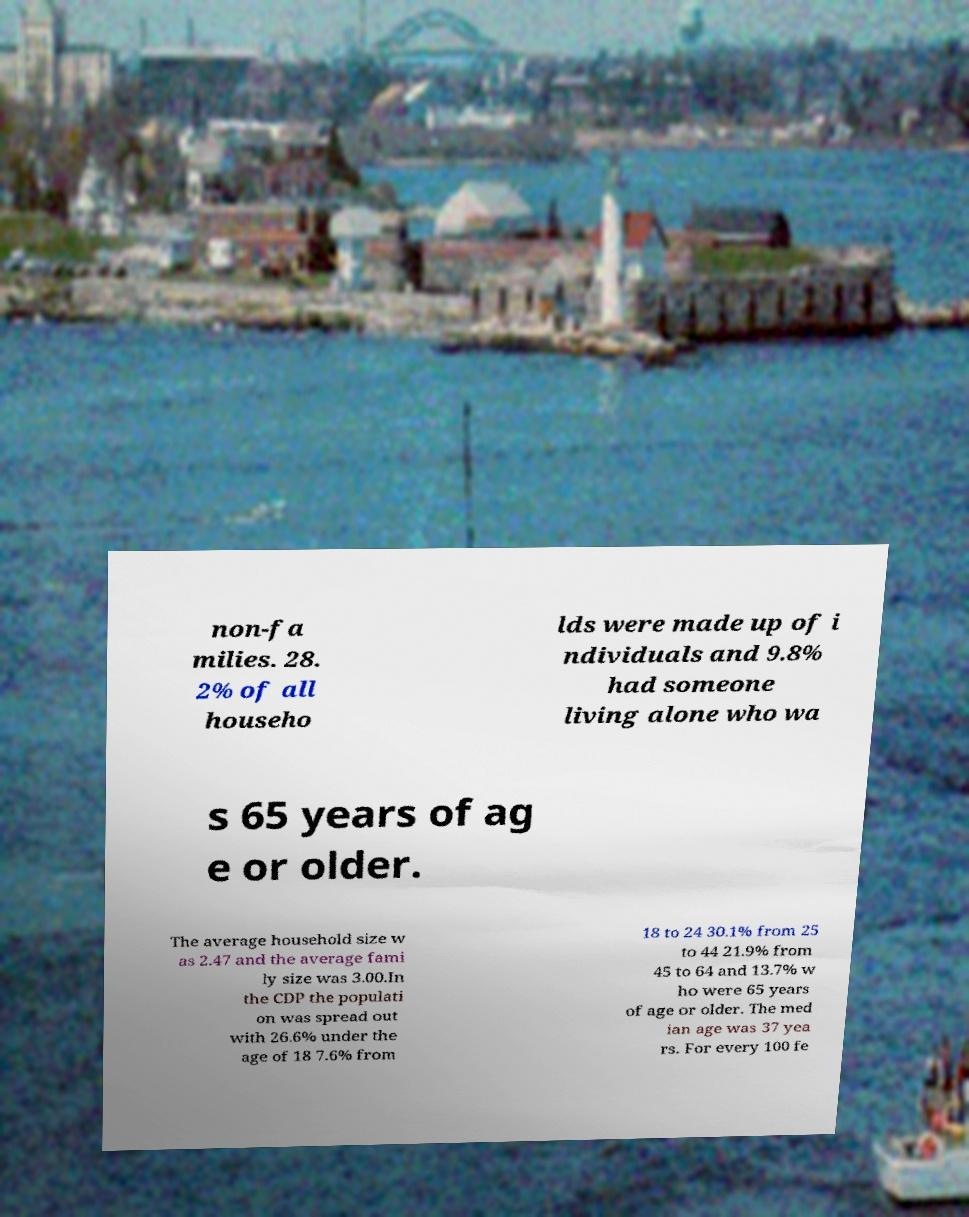I need the written content from this picture converted into text. Can you do that? non-fa milies. 28. 2% of all househo lds were made up of i ndividuals and 9.8% had someone living alone who wa s 65 years of ag e or older. The average household size w as 2.47 and the average fami ly size was 3.00.In the CDP the populati on was spread out with 26.6% under the age of 18 7.6% from 18 to 24 30.1% from 25 to 44 21.9% from 45 to 64 and 13.7% w ho were 65 years of age or older. The med ian age was 37 yea rs. For every 100 fe 